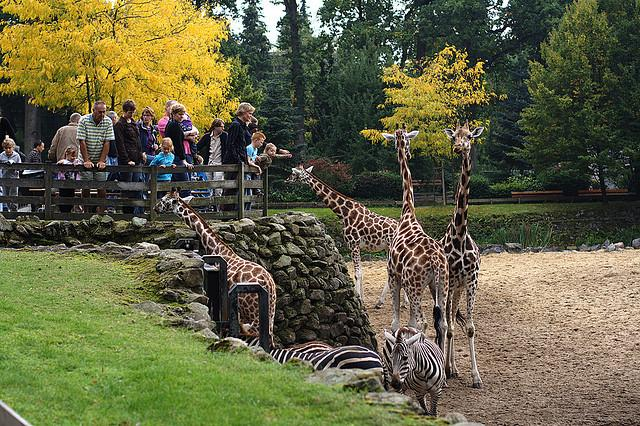How many giraffes are standing in the zoo enclosure around the people?

Choices:
A) four
B) six
C) five
D) three four 